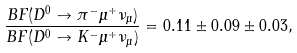<formula> <loc_0><loc_0><loc_500><loc_500>\frac { B F ( D ^ { 0 } \to \pi ^ { - } \mu ^ { + } \nu _ { \mu } ) } { B F ( D ^ { 0 } \to K ^ { - } \mu ^ { + } \nu _ { \mu } ) } = 0 . 1 1 \pm 0 . 0 9 \pm 0 . 0 3 ,</formula> 